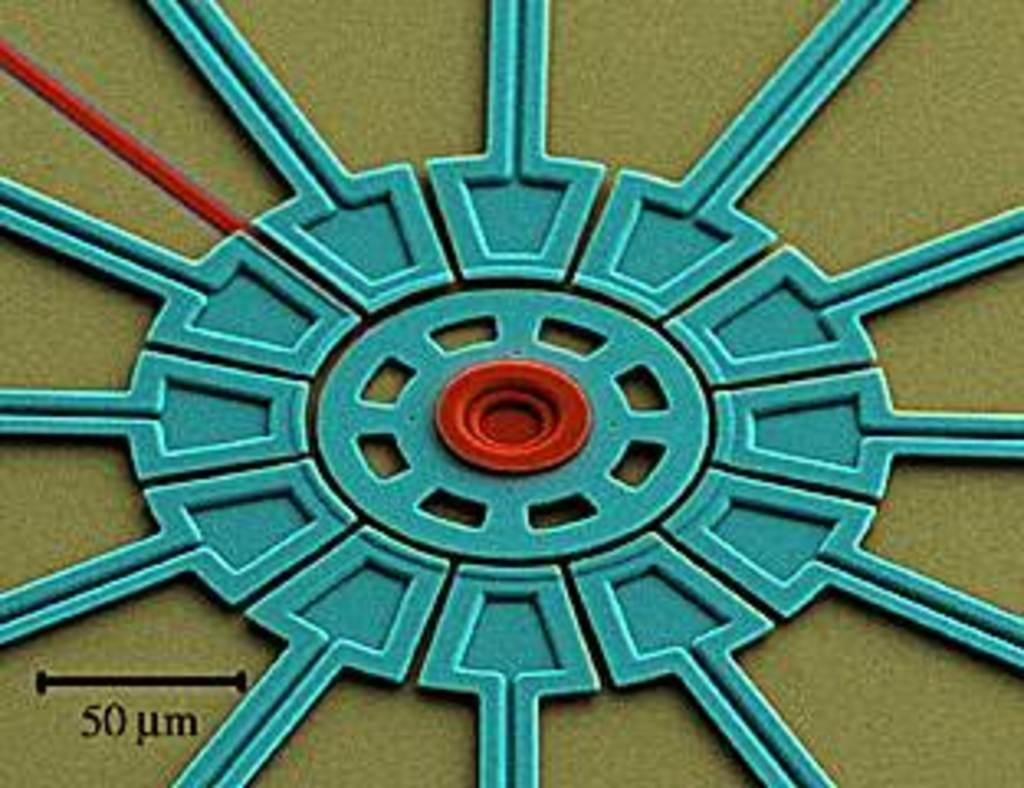What type of picture is in the image? The image contains an animated picture. What is located at the bottom of the image? There is text and numbers at the bottom of the image. What type of brass material can be seen at the edge of the image? There is no brass material present at the edge of the image. 